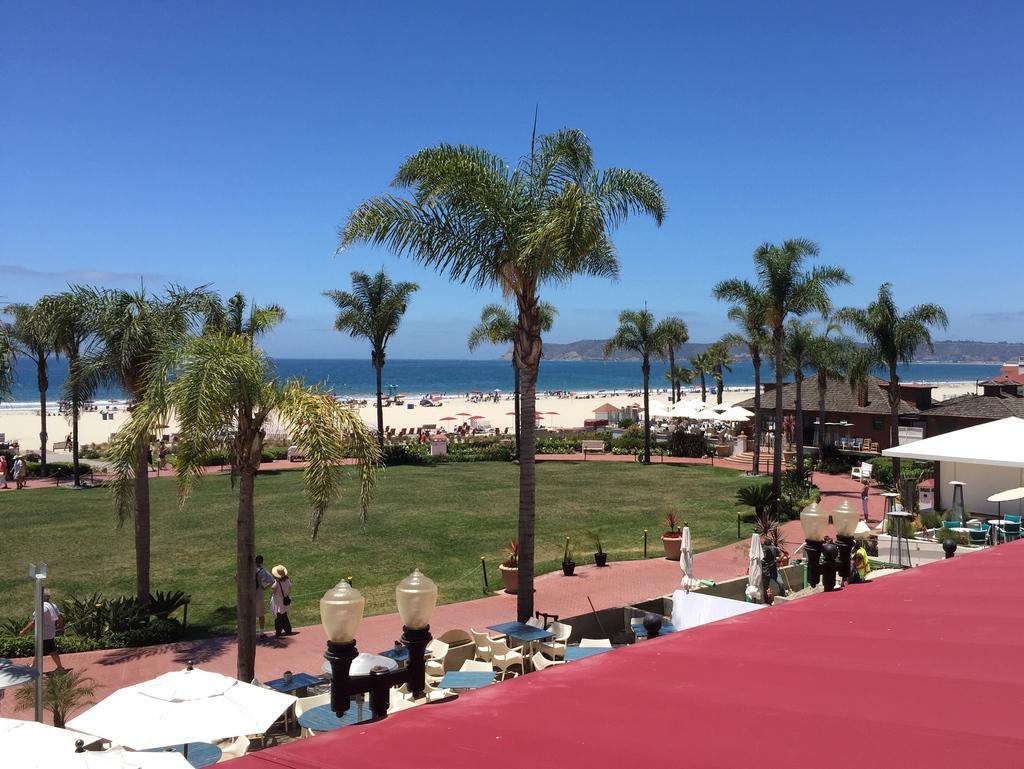How would you summarize this image in a sentence or two? In this image there are some trees in middle of this image and there are some persons standing on the bottom left side of this image, and there are some persons standing on the beach area. there is a sea in the background and there is a sky on the top of this image , and there are some objects kept on the bottom of this image and there are some houses on the right side of this image. 